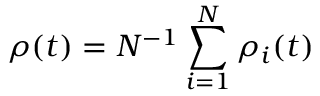Convert formula to latex. <formula><loc_0><loc_0><loc_500><loc_500>\rho ( t ) = N ^ { - 1 } \sum _ { i = 1 } ^ { N } \rho _ { i } ( t )</formula> 